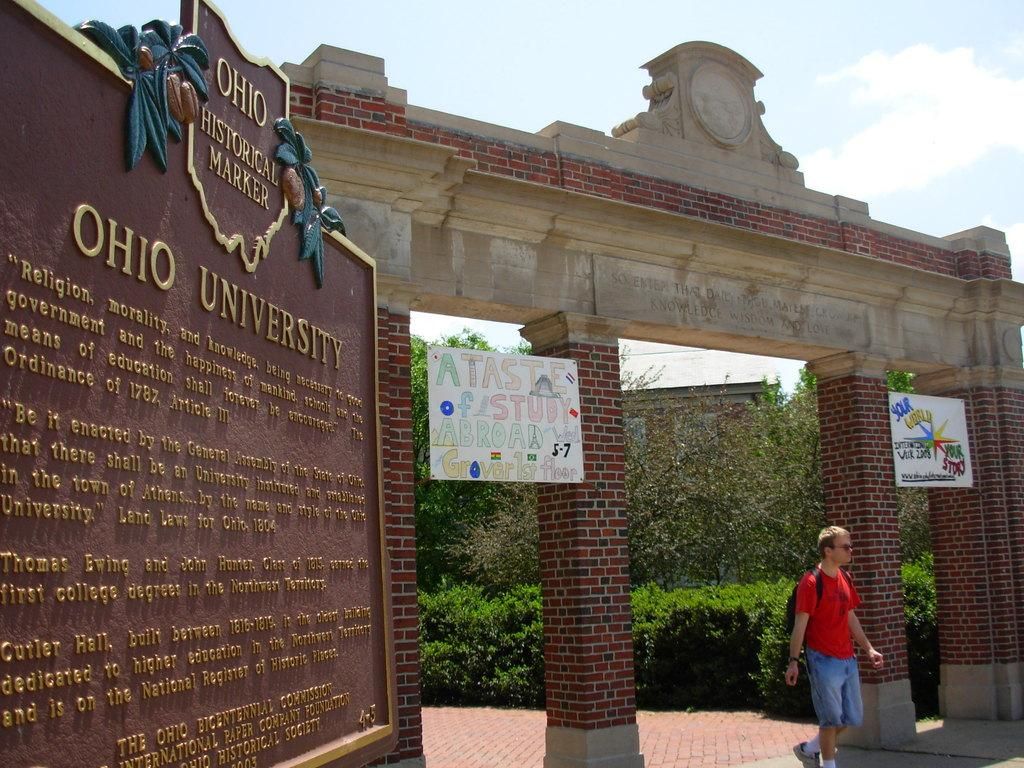What can be seen in the sky in the image? The sky with clouds is visible in the image. What architectural feature is present in the image? There is an entrance arch in the image. What type of vegetation is present in the image? Bushes and trees are visible in the image. What type of structures are present in the image? Buildings are present in the image. What are the people in the image doing? There are persons standing on the floor in the image. What type of information is displayed in the image? There is a chart with some text in the image. What type of material is visible in the image? A laid stone is visible in the image. What type of bait is being used by the person in the image? There is no person using bait in the image. What type of comb is being used by the person in the image? There is no person using a comb in the image. 